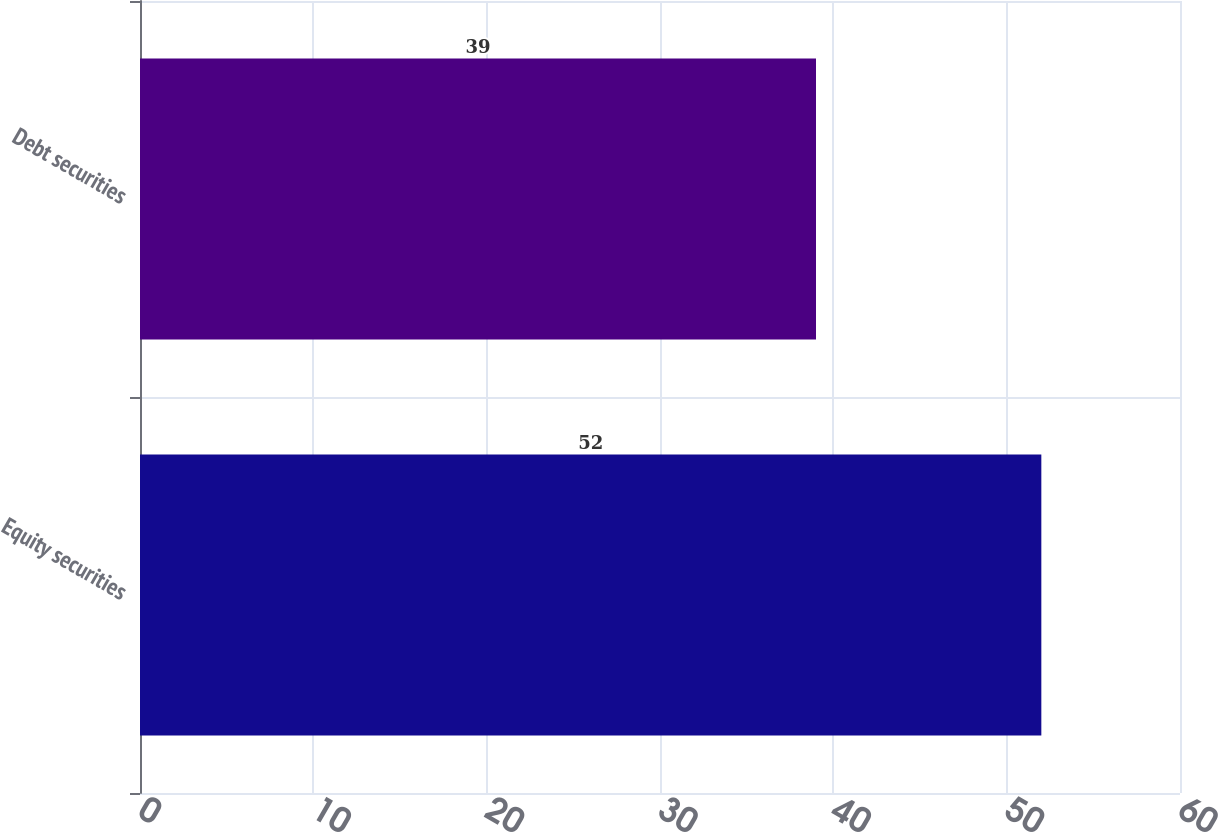<chart> <loc_0><loc_0><loc_500><loc_500><bar_chart><fcel>Equity securities<fcel>Debt securities<nl><fcel>52<fcel>39<nl></chart> 